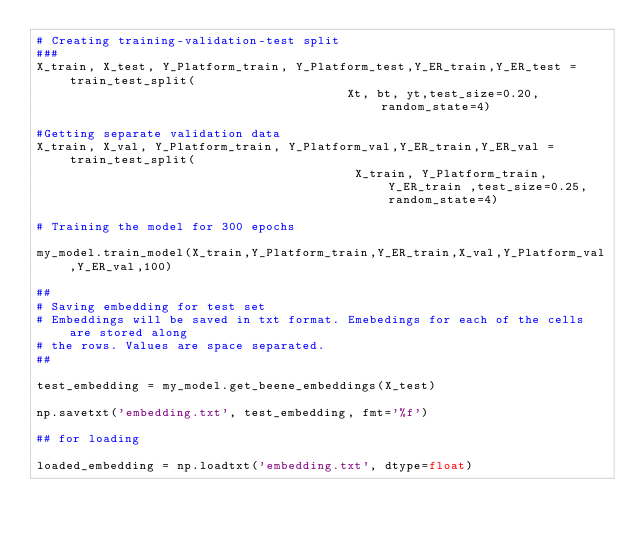<code> <loc_0><loc_0><loc_500><loc_500><_Python_># Creating training-validation-test split
###
X_train, X_test, Y_Platform_train, Y_Platform_test,Y_ER_train,Y_ER_test = train_test_split(
                                          Xt, bt, yt,test_size=0.20,random_state=4)

#Getting separate validation data
X_train, X_val, Y_Platform_train, Y_Platform_val,Y_ER_train,Y_ER_val = train_test_split(
                                           X_train, Y_Platform_train, Y_ER_train ,test_size=0.25,random_state=4)

# Training the model for 300 epochs

my_model.train_model(X_train,Y_Platform_train,Y_ER_train,X_val,Y_Platform_val,Y_ER_val,100)

##
# Saving embedding for test set
# Embeddings will be saved in txt format. Emebedings for each of the cells are stored along
# the rows. Values are space separated. 
##

test_embedding = my_model.get_beene_embeddings(X_test)

np.savetxt('embedding.txt', test_embedding, fmt='%f')

## for loading 

loaded_embedding = np.loadtxt('embedding.txt', dtype=float)</code> 